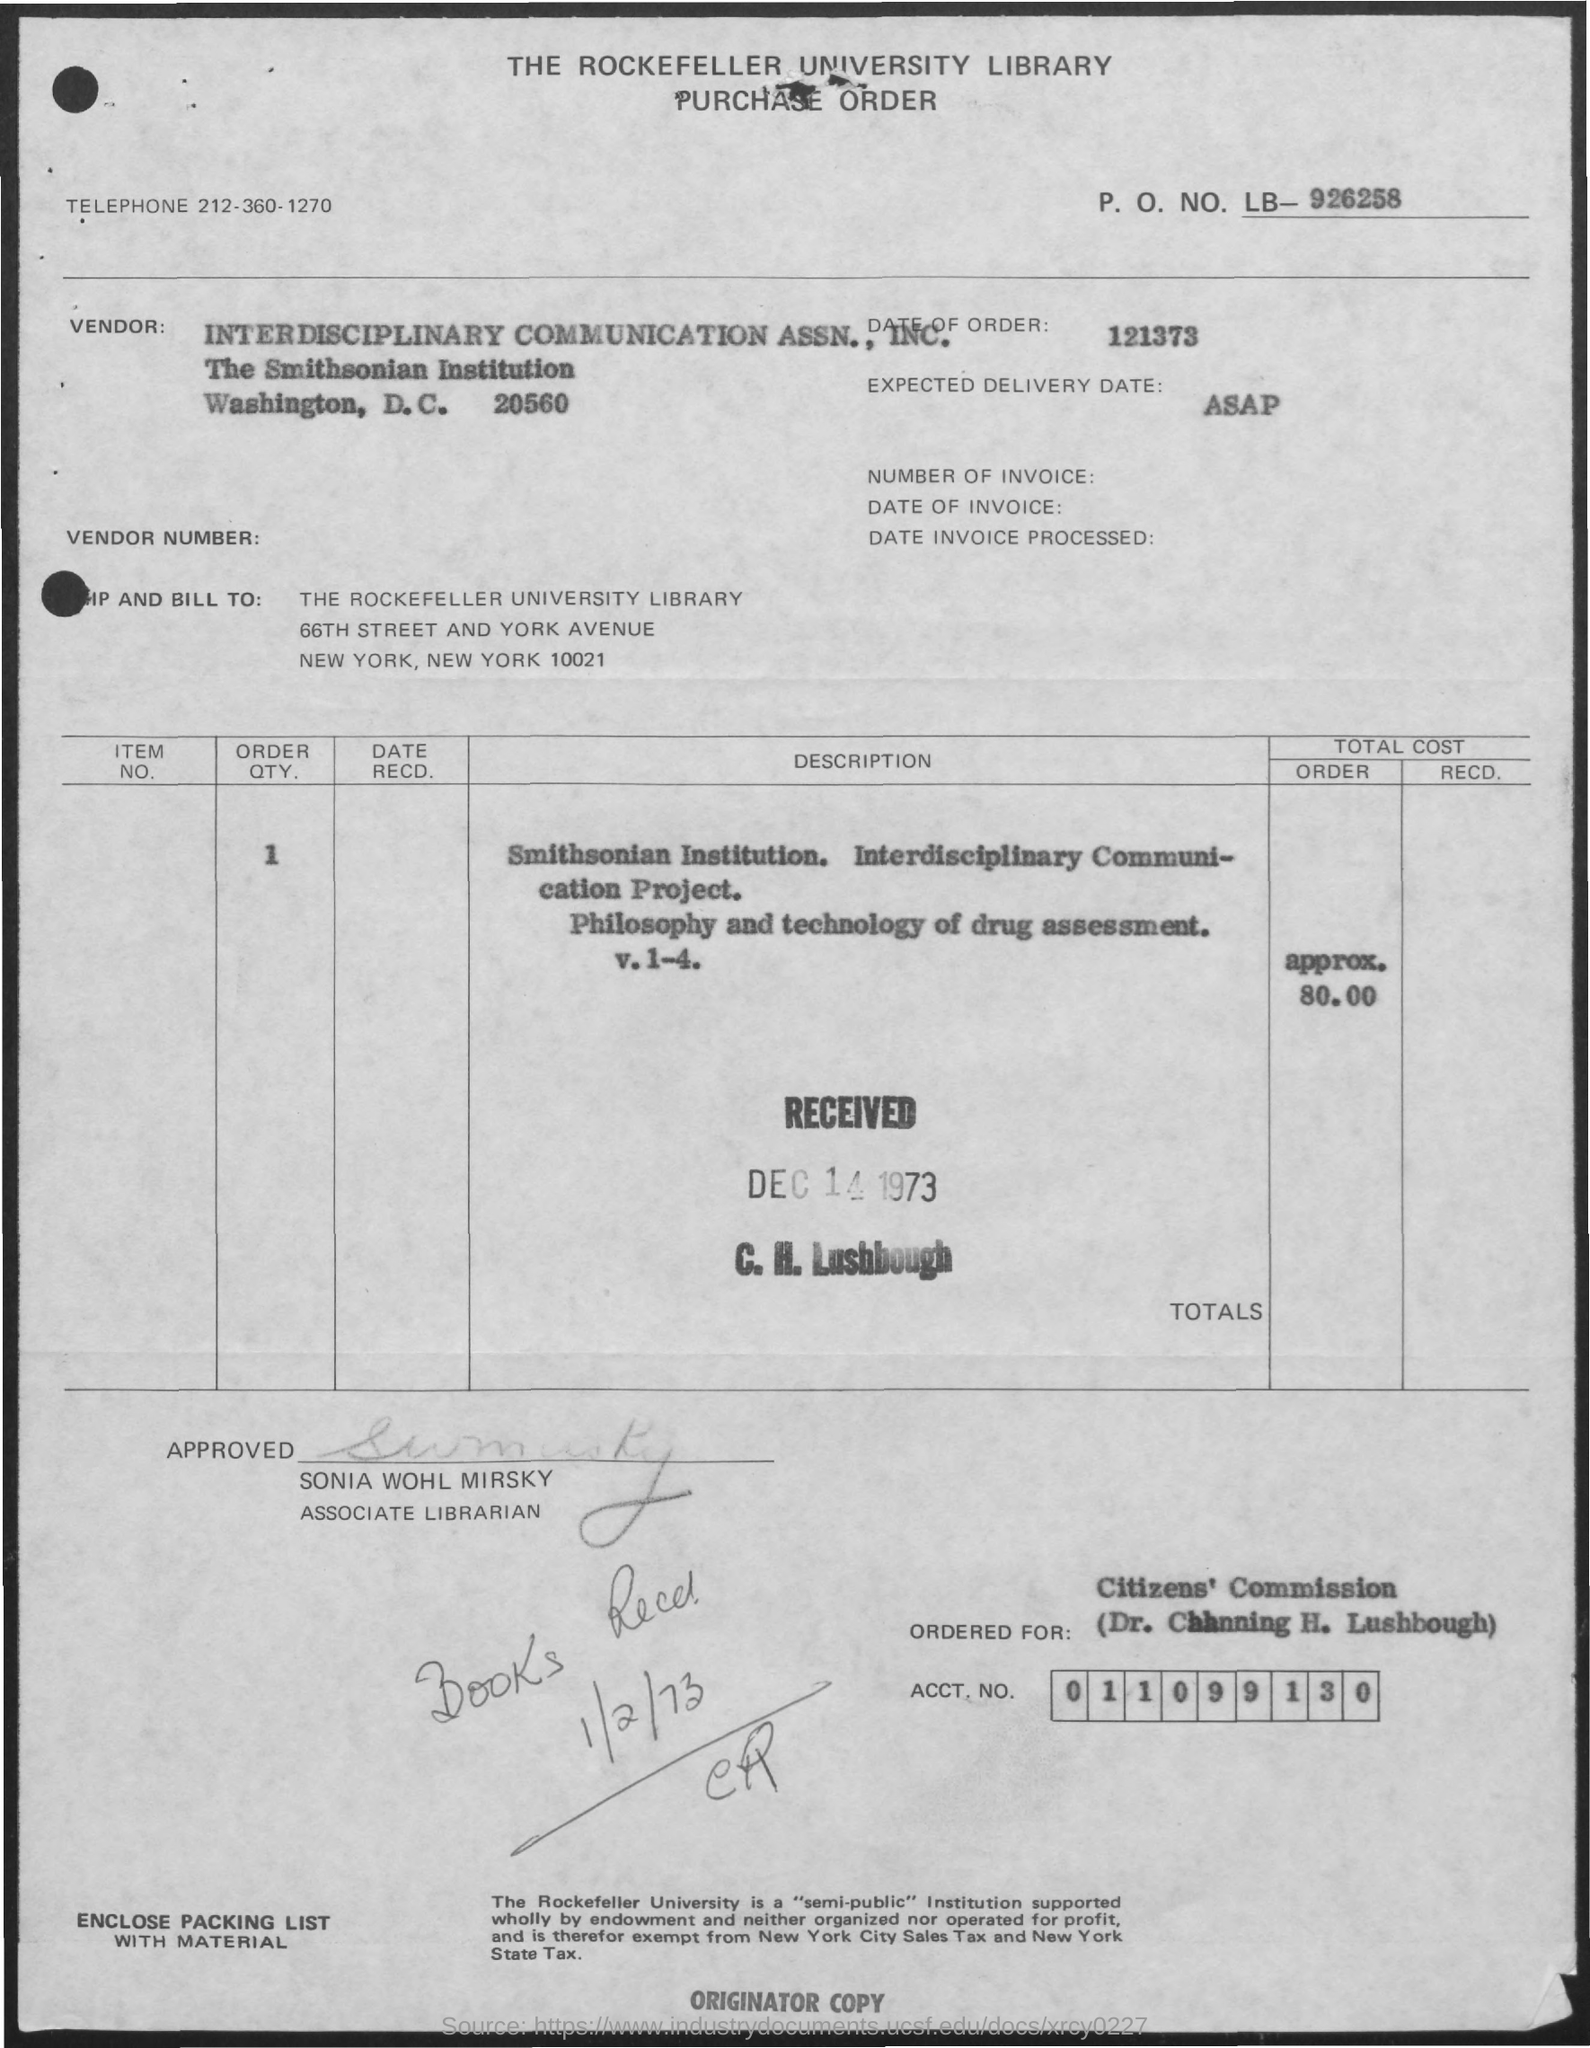What  is the telephone number ?
Offer a terse response. 212-360-1270. What is the name of the associate librarian
Provide a succinct answer. Sonia Wohl Mirsky. How much is the total cost order ?
Make the answer very short. Approx 80.00. What is the date of books recd
Make the answer very short. 1/2/73. What is the expected delivery date
Give a very brief answer. ASAP. 